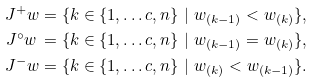<formula> <loc_0><loc_0><loc_500><loc_500>J ^ { + } _ { \ } w & = \{ k \in \{ 1 , \dots c , n \} \ | \ w _ { ( k - 1 ) } < w _ { ( k ) } \} , \\ J ^ { \circ } _ { \ } w \, & = \{ k \in \{ 1 , \dots c , n \} \ | \ w _ { ( k - 1 ) } = w _ { ( k ) } \} , \\ J ^ { - } _ { \ } w & = \{ k \in \{ 1 , \dots c , n \} \ | \ w _ { ( k ) } < w _ { ( k - 1 ) } \} .</formula> 